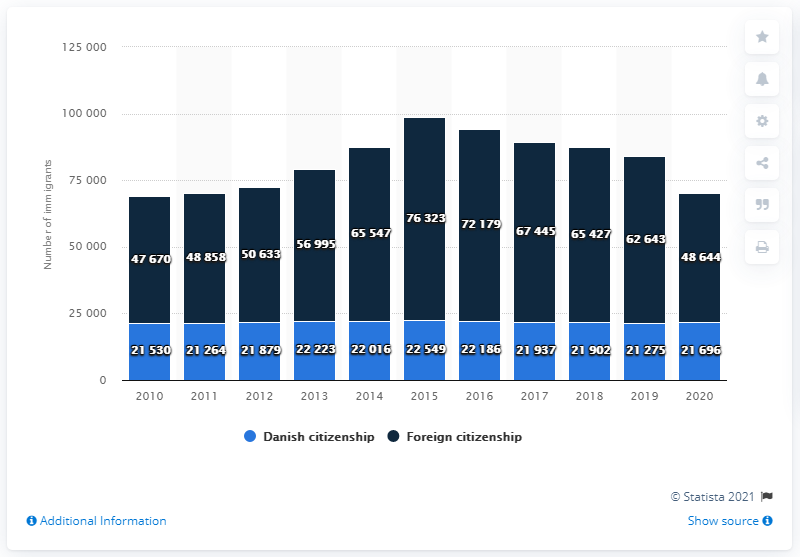Identify some key points in this picture. In 2020, a total of 48,644 individuals who did not hold Danish citizenship immigrated to Denmark. In 2020, a total of 21,696 Danish citizens immigrated to Denmark. 